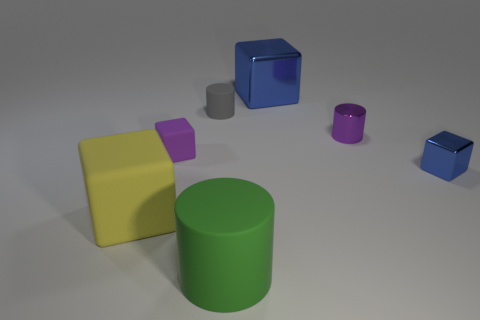There is a small thing that is the same color as the large shiny block; what shape is it?
Ensure brevity in your answer.  Cube. Are there any tiny purple shiny cylinders that are in front of the rubber cube in front of the small shiny block?
Offer a terse response. No. There is a tiny object that is both right of the big blue block and to the left of the tiny shiny cube; what is its material?
Make the answer very short. Metal. What color is the tiny metallic object on the left side of the metallic cube to the right of the metallic thing that is behind the small purple shiny cylinder?
Keep it short and to the point. Purple. There is another rubber object that is the same size as the yellow thing; what is its color?
Give a very brief answer. Green. Is the color of the big shiny thing the same as the tiny rubber object on the left side of the small gray matte cylinder?
Provide a short and direct response. No. What material is the small purple thing that is to the right of the rubber block right of the big matte cube?
Provide a succinct answer. Metal. What number of metal objects are both in front of the large blue shiny object and behind the tiny purple block?
Offer a terse response. 1. What number of other things are the same size as the purple metal thing?
Offer a terse response. 3. Do the tiny object on the right side of the small purple metal thing and the green rubber thing that is in front of the large blue block have the same shape?
Provide a short and direct response. No. 